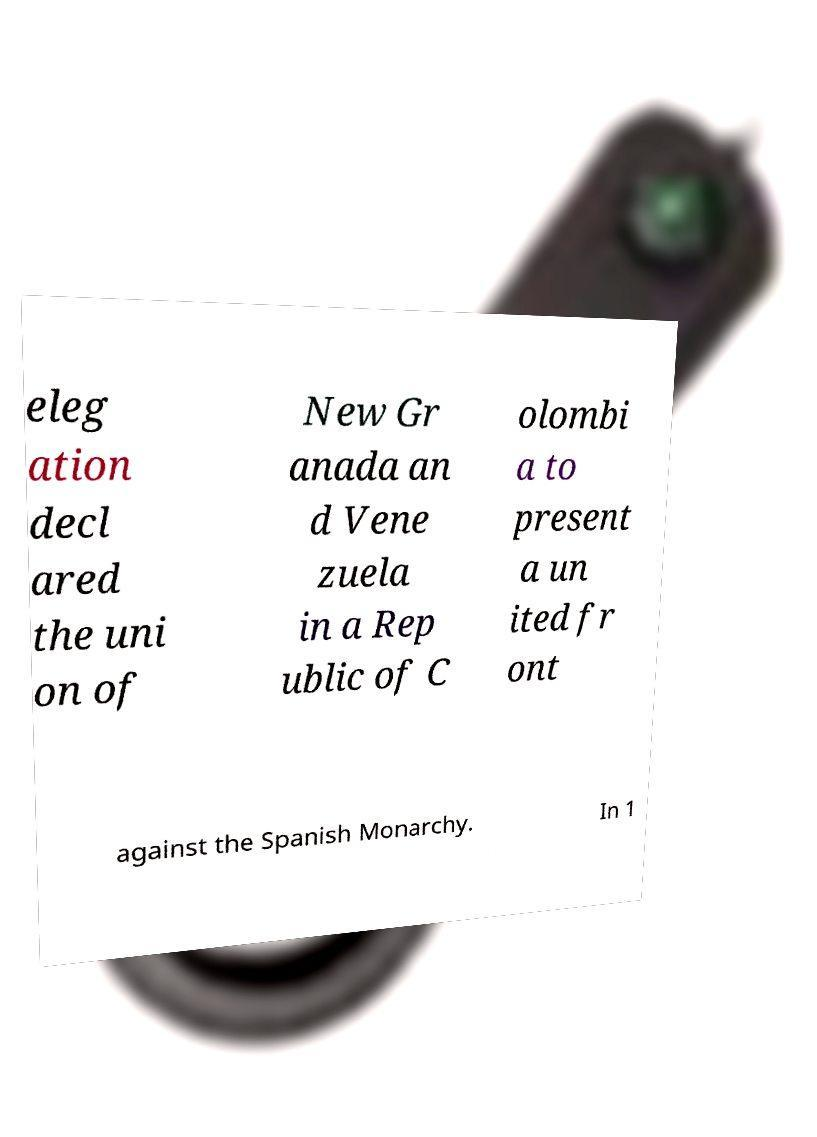Can you accurately transcribe the text from the provided image for me? eleg ation decl ared the uni on of New Gr anada an d Vene zuela in a Rep ublic of C olombi a to present a un ited fr ont against the Spanish Monarchy. In 1 